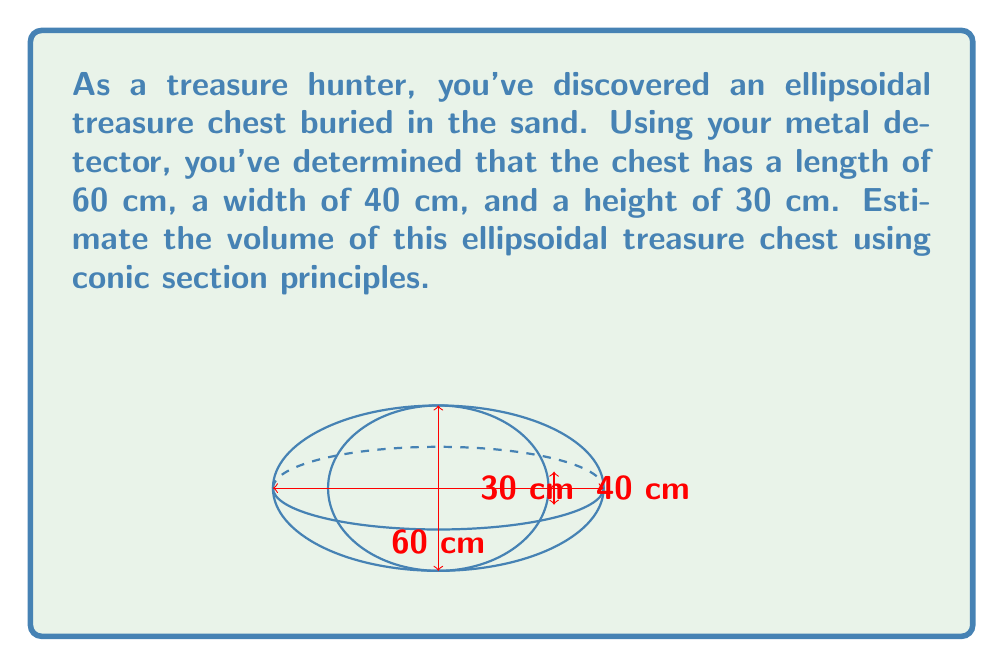Could you help me with this problem? To estimate the volume of an ellipsoidal treasure chest, we can use the formula for the volume of an ellipsoid:

$$V = \frac{4}{3}\pi abc$$

where $a$, $b$, and $c$ are the semi-axes of the ellipsoid.

Given dimensions:
- Length: 60 cm
- Width: 40 cm
- Height: 30 cm

Step 1: Determine the semi-axes
$a = \frac{60}{2} = 30$ cm (half of the length)
$b = \frac{40}{2} = 20$ cm (half of the width)
$c = \frac{30}{2} = 15$ cm (half of the height)

Step 2: Apply the volume formula
$$V = \frac{4}{3}\pi abc$$
$$V = \frac{4}{3}\pi(30)(20)(15)$$

Step 3: Calculate the result
$$V = \frac{4}{3}\pi(9000)$$
$$V = 12000\pi$$
$$V \approx 37699.11184 \text{ cm}^3$$

Step 4: Round to a reasonable number of significant figures
Given that the measurements are likely not precise to the millimeter, we can round our answer to the nearest hundred cubic centimeters.

$$V \approx 37700 \text{ cm}^3$$
Answer: $37700 \text{ cm}^3$ 